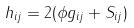<formula> <loc_0><loc_0><loc_500><loc_500>h _ { i j } = 2 ( \phi g _ { i j } + S _ { i j } )</formula> 